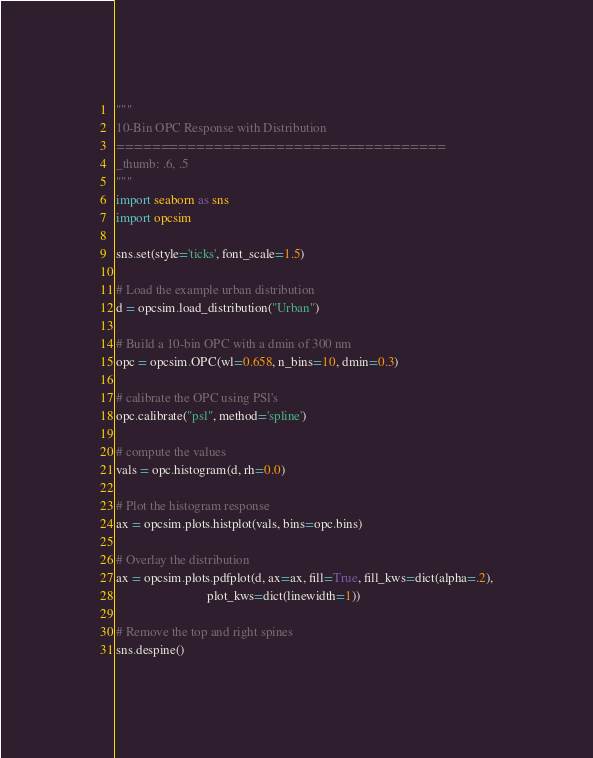Convert code to text. <code><loc_0><loc_0><loc_500><loc_500><_Python_>"""
10-Bin OPC Response with Distribution
=====================================
_thumb: .6, .5
"""
import seaborn as sns
import opcsim

sns.set(style='ticks', font_scale=1.5)

# Load the example urban distribution
d = opcsim.load_distribution("Urban")

# Build a 10-bin OPC with a dmin of 300 nm
opc = opcsim.OPC(wl=0.658, n_bins=10, dmin=0.3)

# calibrate the OPC using PSl's
opc.calibrate("psl", method='spline')

# compute the values
vals = opc.histogram(d, rh=0.0)

# Plot the histogram response
ax = opcsim.plots.histplot(vals, bins=opc.bins)

# Overlay the distribution
ax = opcsim.plots.pdfplot(d, ax=ax, fill=True, fill_kws=dict(alpha=.2),
                            plot_kws=dict(linewidth=1))

# Remove the top and right spines
sns.despine()

</code> 